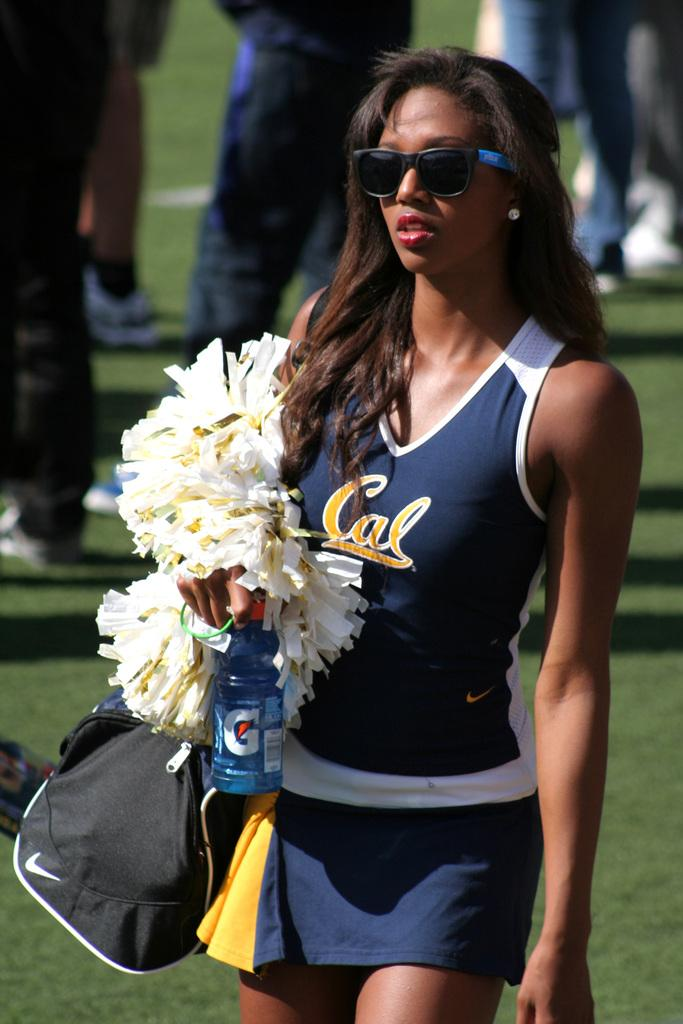<image>
Create a compact narrative representing the image presented. A cheerleader in a Cal tank carries her bag along with a drink and pom poms. 